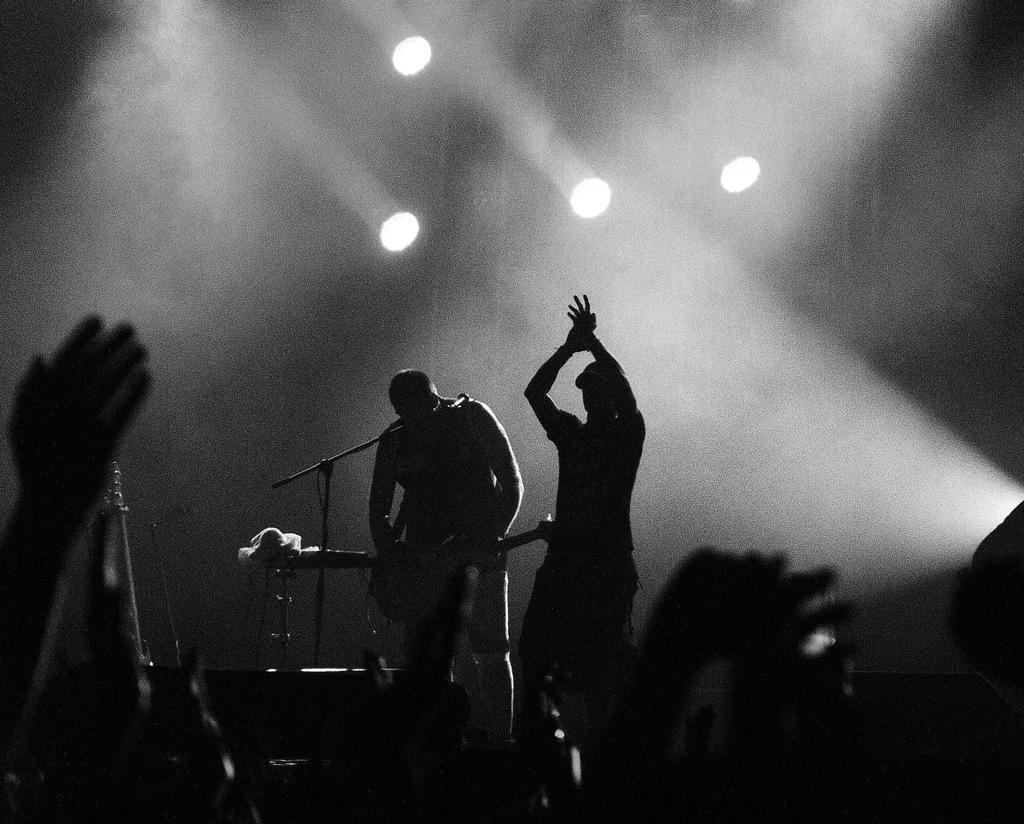How many people are in the image? There are two persons in the image. What are the persons doing in the image? The persons are playing musical instruments. What can be seen in the background or surroundings of the image? There are lights visible in the image. What is the color scheme of the image? The image is in black and white. How many rabbits are hopping on the floor in the image? There are no rabbits present in the image, and the floor is not visible. Is there any mention of payment or financial transactions in the image? There is no mention of payment or financial transactions in the image. 